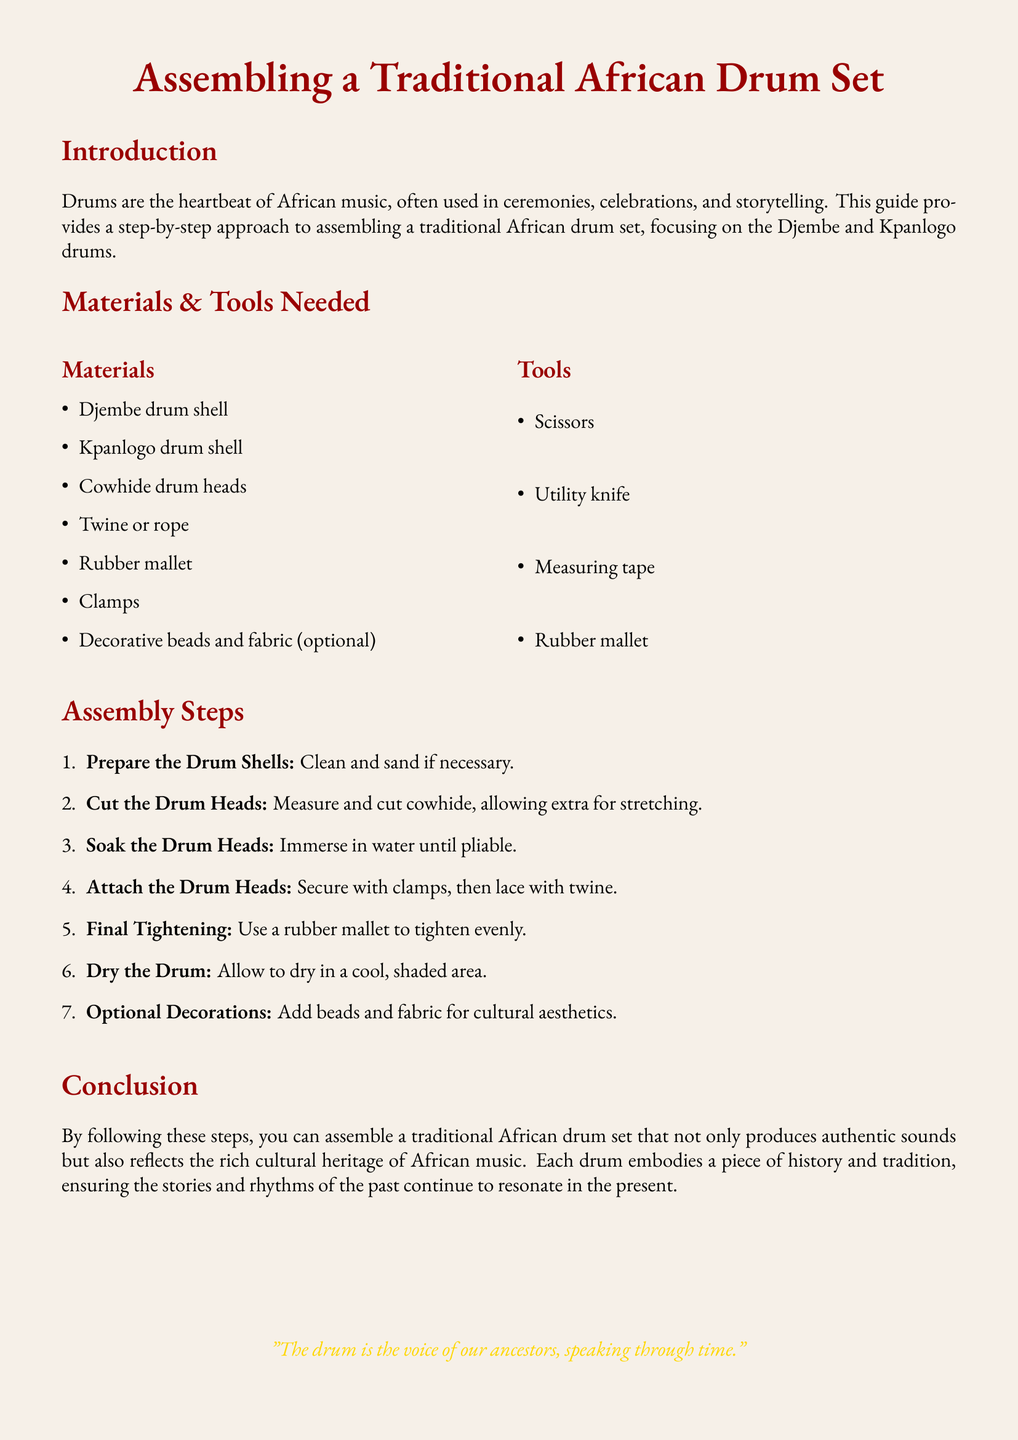what is the main focus of the guide? The guide focuses on assembling a traditional African drum set, specifically the Djembe and Kpanlogo drums.
Answer: assembling a traditional African drum set how many drum shells are listed in the materials? The document mentions two types of drum shells needed for the assembly.
Answer: two which tool is used for tightening the drum? The rubber mallet is specifically mentioned as the tool used for the final tightening step in the assembly.
Answer: rubber mallet what step involves soaking the drum heads? The step where soaking the drum heads is mentioned comes after cutting them and is crucial for making them pliable.
Answer: Step 3 what optional item can be added for cultural aesthetics? The text specifies that decorative beads and fabric can be added as an optional decoration for enhancing cultural aesthetics.
Answer: beads and fabric how many materials are listed in total? There are a total of seven material items listed for the drum assembly.
Answer: seven what is the purpose of the assembly guide? The purpose of the guide is to provide a step-by-step approach to assembling a drum set that reflects African cultural heritage.
Answer: provide a step-by-step approach what should be done to the drum after assembly? The preparation includes allowing the assembled drum to dry in a cool shaded area after it has been tightened.
Answer: dry the drum 